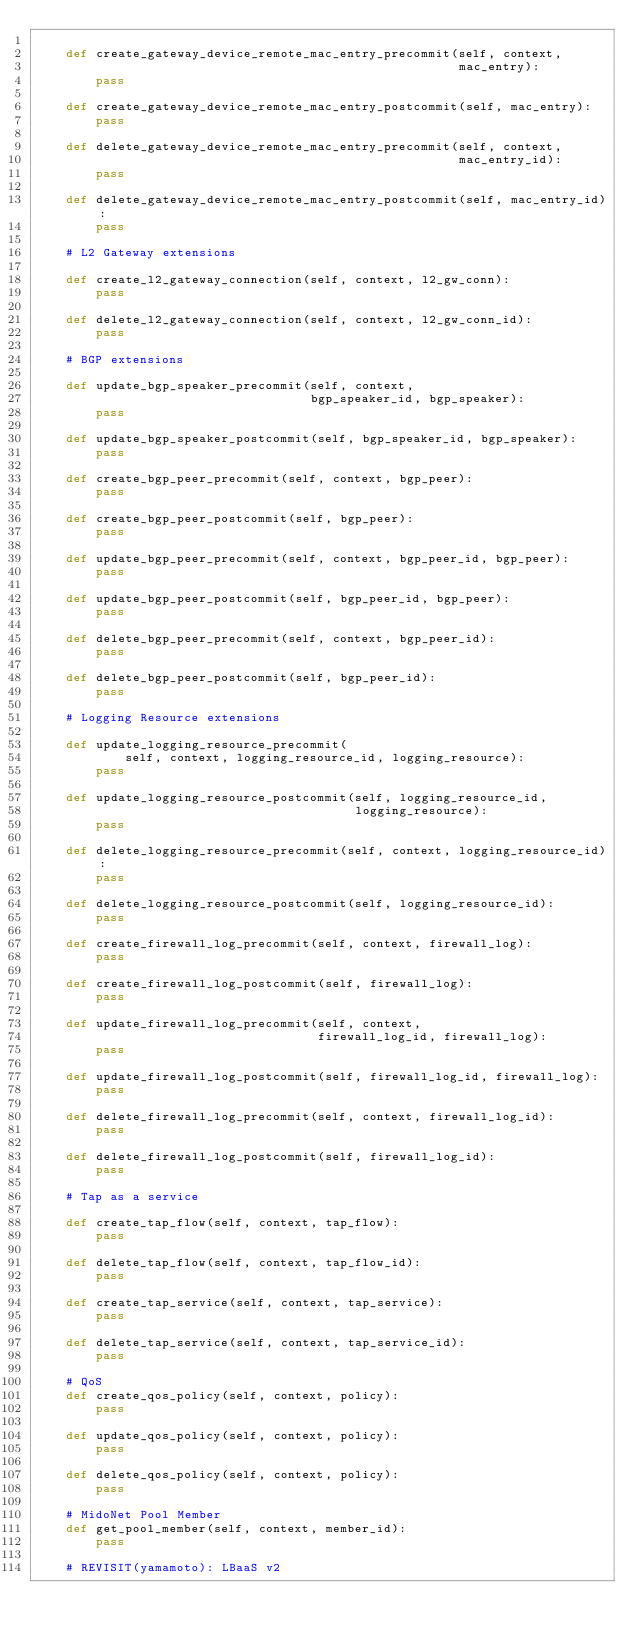Convert code to text. <code><loc_0><loc_0><loc_500><loc_500><_Python_>
    def create_gateway_device_remote_mac_entry_precommit(self, context,
                                                         mac_entry):
        pass

    def create_gateway_device_remote_mac_entry_postcommit(self, mac_entry):
        pass

    def delete_gateway_device_remote_mac_entry_precommit(self, context,
                                                         mac_entry_id):
        pass

    def delete_gateway_device_remote_mac_entry_postcommit(self, mac_entry_id):
        pass

    # L2 Gateway extensions

    def create_l2_gateway_connection(self, context, l2_gw_conn):
        pass

    def delete_l2_gateway_connection(self, context, l2_gw_conn_id):
        pass

    # BGP extensions

    def update_bgp_speaker_precommit(self, context,
                                     bgp_speaker_id, bgp_speaker):
        pass

    def update_bgp_speaker_postcommit(self, bgp_speaker_id, bgp_speaker):
        pass

    def create_bgp_peer_precommit(self, context, bgp_peer):
        pass

    def create_bgp_peer_postcommit(self, bgp_peer):
        pass

    def update_bgp_peer_precommit(self, context, bgp_peer_id, bgp_peer):
        pass

    def update_bgp_peer_postcommit(self, bgp_peer_id, bgp_peer):
        pass

    def delete_bgp_peer_precommit(self, context, bgp_peer_id):
        pass

    def delete_bgp_peer_postcommit(self, bgp_peer_id):
        pass

    # Logging Resource extensions

    def update_logging_resource_precommit(
            self, context, logging_resource_id, logging_resource):
        pass

    def update_logging_resource_postcommit(self, logging_resource_id,
                                           logging_resource):
        pass

    def delete_logging_resource_precommit(self, context, logging_resource_id):
        pass

    def delete_logging_resource_postcommit(self, logging_resource_id):
        pass

    def create_firewall_log_precommit(self, context, firewall_log):
        pass

    def create_firewall_log_postcommit(self, firewall_log):
        pass

    def update_firewall_log_precommit(self, context,
                                      firewall_log_id, firewall_log):
        pass

    def update_firewall_log_postcommit(self, firewall_log_id, firewall_log):
        pass

    def delete_firewall_log_precommit(self, context, firewall_log_id):
        pass

    def delete_firewall_log_postcommit(self, firewall_log_id):
        pass

    # Tap as a service

    def create_tap_flow(self, context, tap_flow):
        pass

    def delete_tap_flow(self, context, tap_flow_id):
        pass

    def create_tap_service(self, context, tap_service):
        pass

    def delete_tap_service(self, context, tap_service_id):
        pass

    # QoS
    def create_qos_policy(self, context, policy):
        pass

    def update_qos_policy(self, context, policy):
        pass

    def delete_qos_policy(self, context, policy):
        pass

    # MidoNet Pool Member
    def get_pool_member(self, context, member_id):
        pass

    # REVISIT(yamamoto): LBaaS v2
</code> 